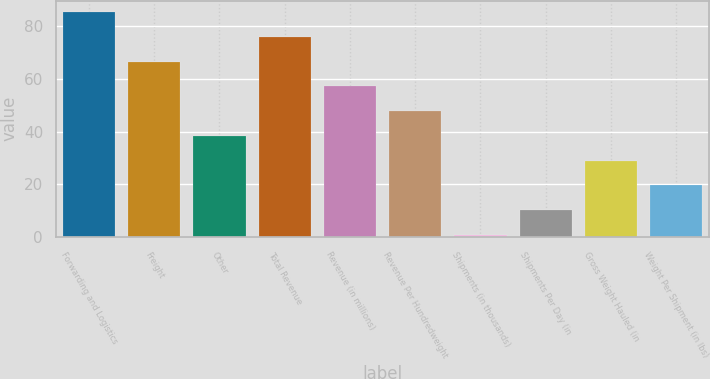Convert chart. <chart><loc_0><loc_0><loc_500><loc_500><bar_chart><fcel>Forwarding and Logistics<fcel>Freight<fcel>Other<fcel>Total Revenue<fcel>Revenue (in millions)<fcel>Revenue Per Hundredweight<fcel>Shipments (in thousands)<fcel>Shipments Per Day (in<fcel>Gross Weight Hauled (in<fcel>Weight Per Shipment (in lbs)<nl><fcel>85.48<fcel>66.64<fcel>38.38<fcel>76.06<fcel>57.22<fcel>47.8<fcel>0.7<fcel>10.12<fcel>28.96<fcel>19.54<nl></chart> 